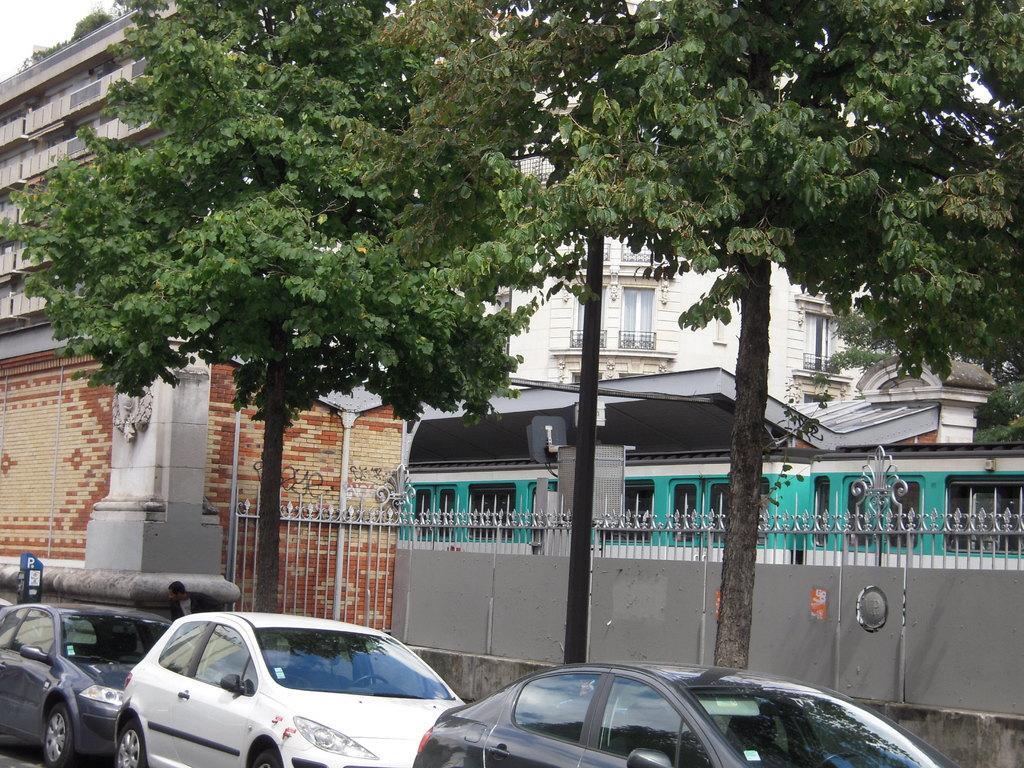How would you summarize this image in a sentence or two? In this image, there are buildings, trees, iron grilles and a pole. At the bottom of the image, I can see a person and there are cars. On the left side of the image, it looks like a parking meter. 